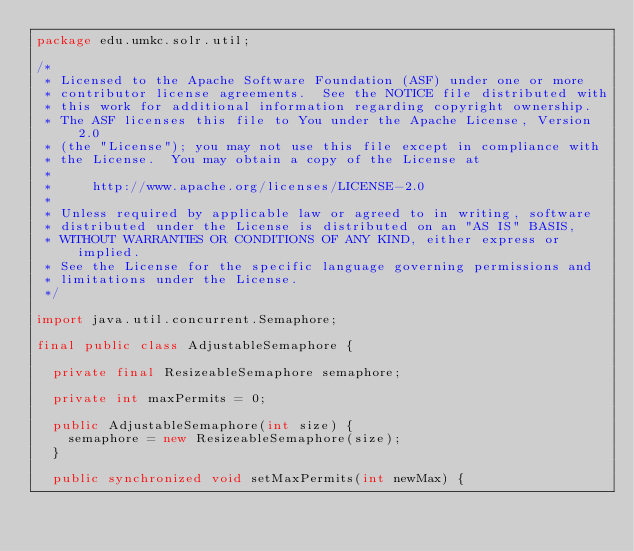<code> <loc_0><loc_0><loc_500><loc_500><_Java_>package edu.umkc.solr.util;

/*
 * Licensed to the Apache Software Foundation (ASF) under one or more
 * contributor license agreements.  See the NOTICE file distributed with
 * this work for additional information regarding copyright ownership.
 * The ASF licenses this file to You under the Apache License, Version 2.0
 * (the "License"); you may not use this file except in compliance with
 * the License.  You may obtain a copy of the License at
 *
 *     http://www.apache.org/licenses/LICENSE-2.0
 *
 * Unless required by applicable law or agreed to in writing, software
 * distributed under the License is distributed on an "AS IS" BASIS,
 * WITHOUT WARRANTIES OR CONDITIONS OF ANY KIND, either express or implied.
 * See the License for the specific language governing permissions and
 * limitations under the License.
 */

import java.util.concurrent.Semaphore;

final public class AdjustableSemaphore {

  private final ResizeableSemaphore semaphore;
  
  private int maxPermits = 0;

  public AdjustableSemaphore(int size) {
    semaphore = new ResizeableSemaphore(size);
  }
  
  public synchronized void setMaxPermits(int newMax) {</code> 